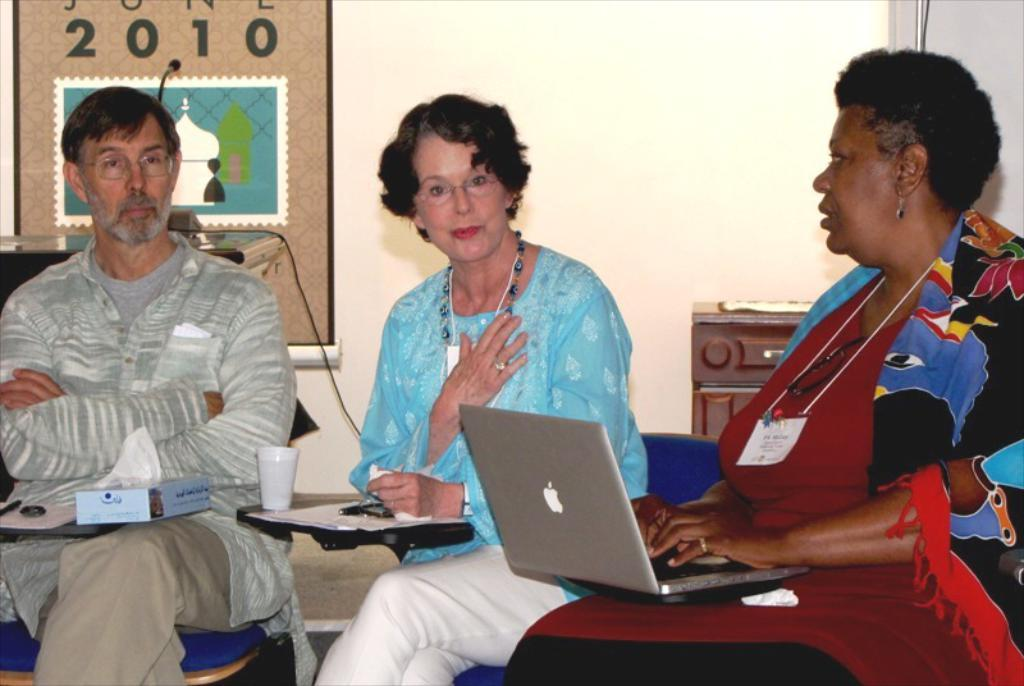How many people are present in the image? There are three people in the image. What are the people doing in the image? The people are sitting on chairs and have laptops in their laps. What can be seen in the background of the image? There is a wall in the background of the image. What type of receipt can be seen on the cart in the image? There is no cart or receipt present in the image. What is the people drinking in the image? The image does not show the people drinking anything, as they are focused on using their laptops. 